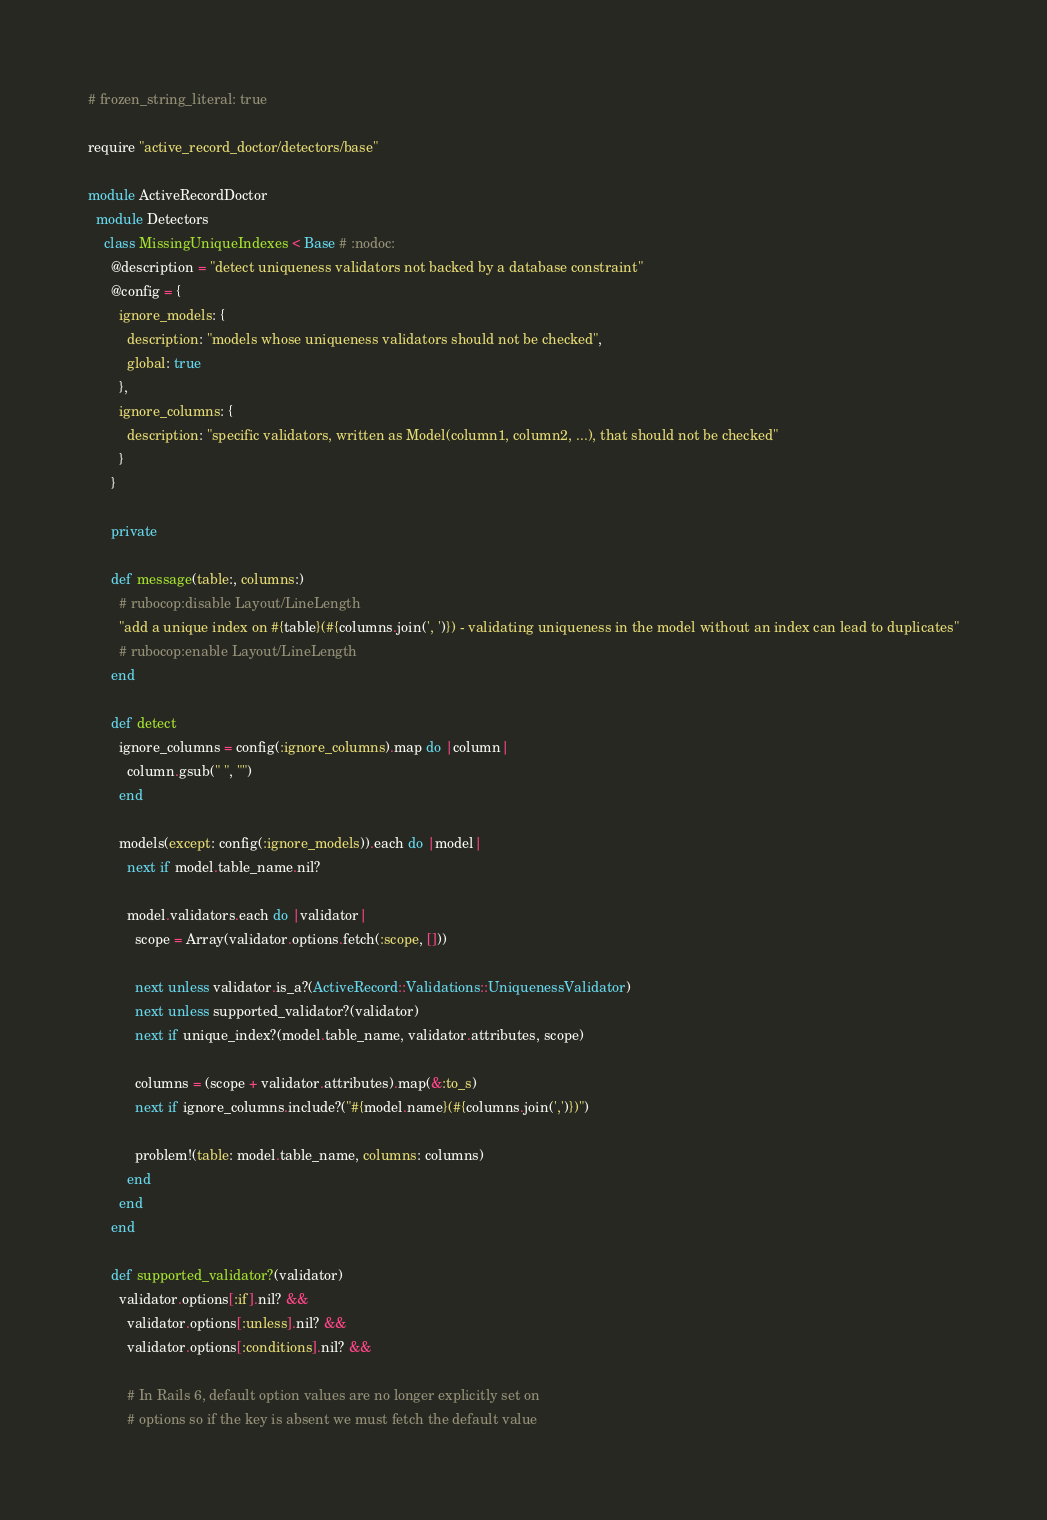<code> <loc_0><loc_0><loc_500><loc_500><_Ruby_># frozen_string_literal: true

require "active_record_doctor/detectors/base"

module ActiveRecordDoctor
  module Detectors
    class MissingUniqueIndexes < Base # :nodoc:
      @description = "detect uniqueness validators not backed by a database constraint"
      @config = {
        ignore_models: {
          description: "models whose uniqueness validators should not be checked",
          global: true
        },
        ignore_columns: {
          description: "specific validators, written as Model(column1, column2, ...), that should not be checked"
        }
      }

      private

      def message(table:, columns:)
        # rubocop:disable Layout/LineLength
        "add a unique index on #{table}(#{columns.join(', ')}) - validating uniqueness in the model without an index can lead to duplicates"
        # rubocop:enable Layout/LineLength
      end

      def detect
        ignore_columns = config(:ignore_columns).map do |column|
          column.gsub(" ", "")
        end

        models(except: config(:ignore_models)).each do |model|
          next if model.table_name.nil?

          model.validators.each do |validator|
            scope = Array(validator.options.fetch(:scope, []))

            next unless validator.is_a?(ActiveRecord::Validations::UniquenessValidator)
            next unless supported_validator?(validator)
            next if unique_index?(model.table_name, validator.attributes, scope)

            columns = (scope + validator.attributes).map(&:to_s)
            next if ignore_columns.include?("#{model.name}(#{columns.join(',')})")

            problem!(table: model.table_name, columns: columns)
          end
        end
      end

      def supported_validator?(validator)
        validator.options[:if].nil? &&
          validator.options[:unless].nil? &&
          validator.options[:conditions].nil? &&

          # In Rails 6, default option values are no longer explicitly set on
          # options so if the key is absent we must fetch the default value</code> 